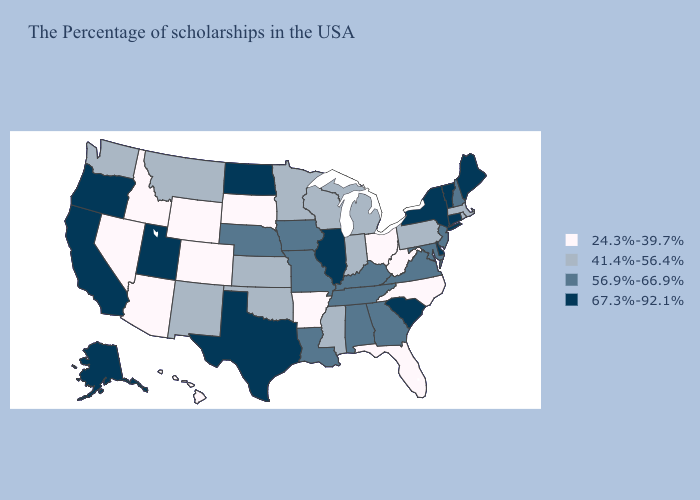What is the lowest value in the South?
Short answer required. 24.3%-39.7%. Does Colorado have a lower value than North Dakota?
Concise answer only. Yes. Name the states that have a value in the range 67.3%-92.1%?
Be succinct. Maine, Vermont, Connecticut, New York, Delaware, South Carolina, Illinois, Texas, North Dakota, Utah, California, Oregon, Alaska. Does Ohio have the lowest value in the MidWest?
Keep it brief. Yes. Is the legend a continuous bar?
Keep it brief. No. What is the value of Maryland?
Keep it brief. 56.9%-66.9%. Does Montana have the same value as Missouri?
Write a very short answer. No. What is the value of Washington?
Be succinct. 41.4%-56.4%. Name the states that have a value in the range 67.3%-92.1%?
Quick response, please. Maine, Vermont, Connecticut, New York, Delaware, South Carolina, Illinois, Texas, North Dakota, Utah, California, Oregon, Alaska. Does Mississippi have the lowest value in the USA?
Short answer required. No. Name the states that have a value in the range 24.3%-39.7%?
Quick response, please. North Carolina, West Virginia, Ohio, Florida, Arkansas, South Dakota, Wyoming, Colorado, Arizona, Idaho, Nevada, Hawaii. What is the value of Kansas?
Answer briefly. 41.4%-56.4%. What is the lowest value in states that border Indiana?
Answer briefly. 24.3%-39.7%. 